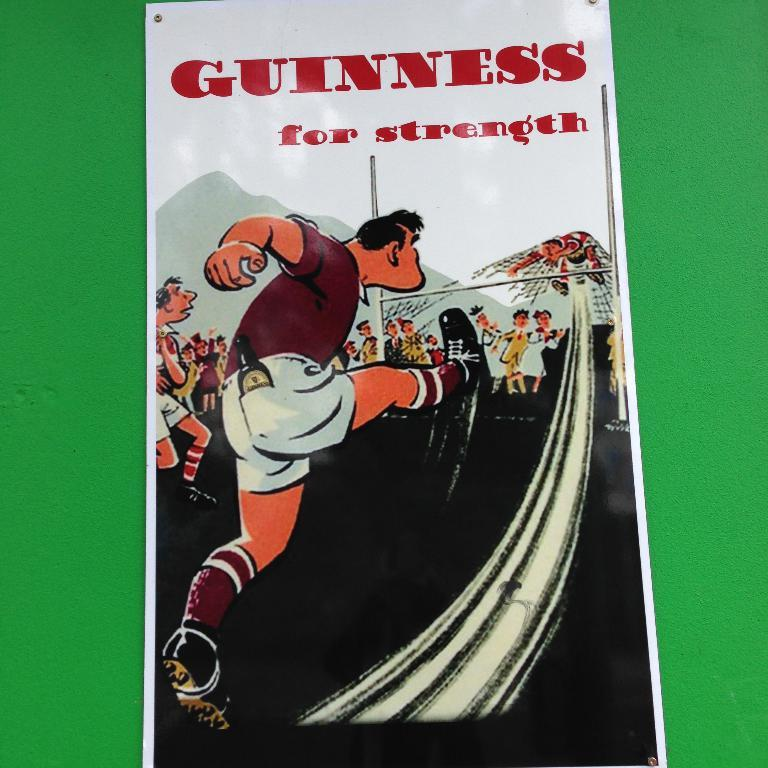<image>
Give a short and clear explanation of the subsequent image. A man kicks a ball into a goalies stomach under the words Guinness For Strength. 